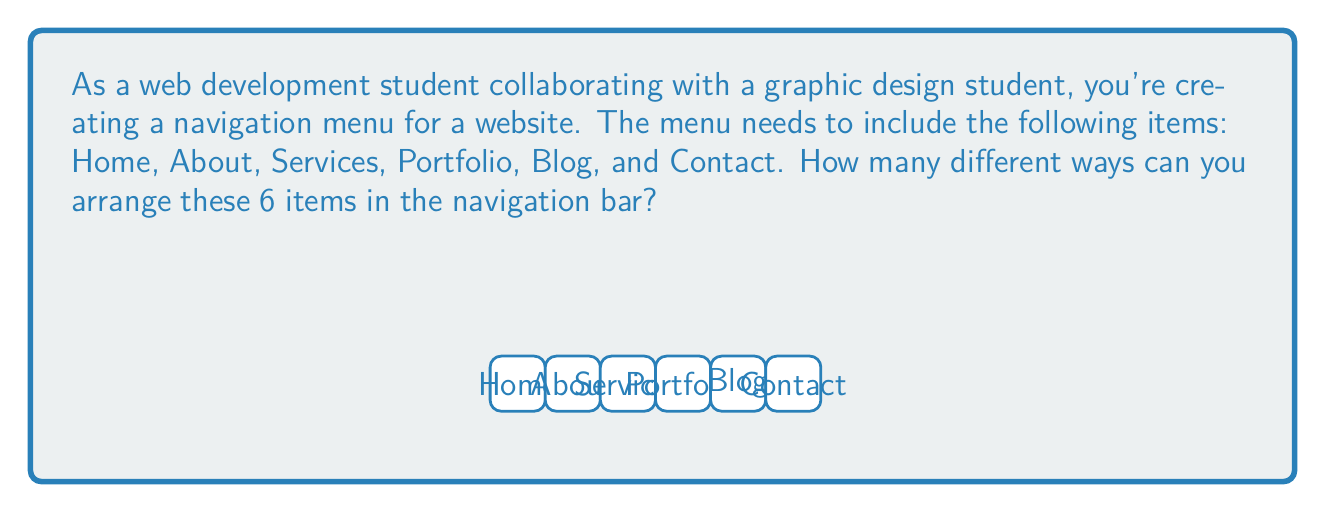Could you help me with this problem? To solve this problem, we need to use the concept of permutations. Since we are arranging all 6 items and the order matters (each arrangement creates a different layout), this is a straightforward permutation problem.

The number of permutations of $n$ distinct objects is given by $n!$ (n factorial).

In this case, we have 6 distinct menu items:
1. Home
2. About
3. Services
4. Portfolio
5. Blog
6. Contact

Therefore, $n = 6$

The number of ways to arrange these items is:

$6! = 6 \times 5 \times 4 \times 3 \times 2 \times 1 = 720$

This means there are 720 different ways to arrange these 6 navigation menu items.

To break it down:
- There are 6 choices for the first position
- For each of those, there are 5 choices for the second position
- For each of those, there are 4 choices for the third position
- And so on...

This multiplication of choices leads to the factorial calculation.
Answer: $720$ 